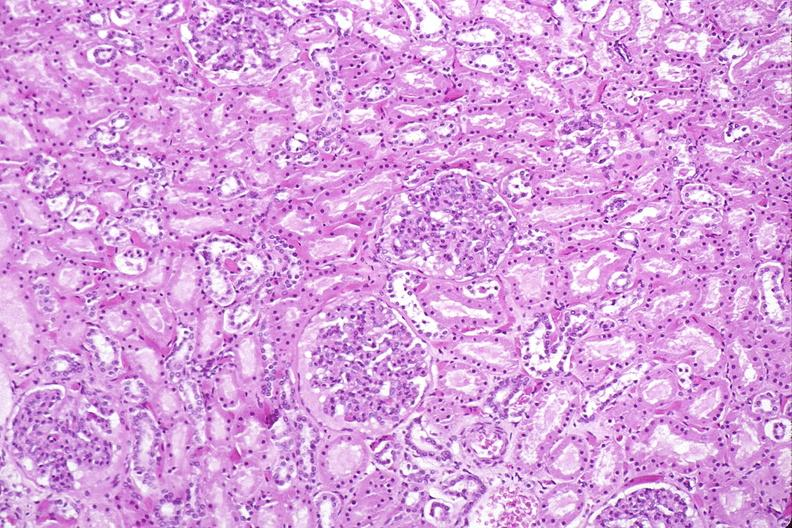does this image show kidney, normal histology?
Answer the question using a single word or phrase. Yes 